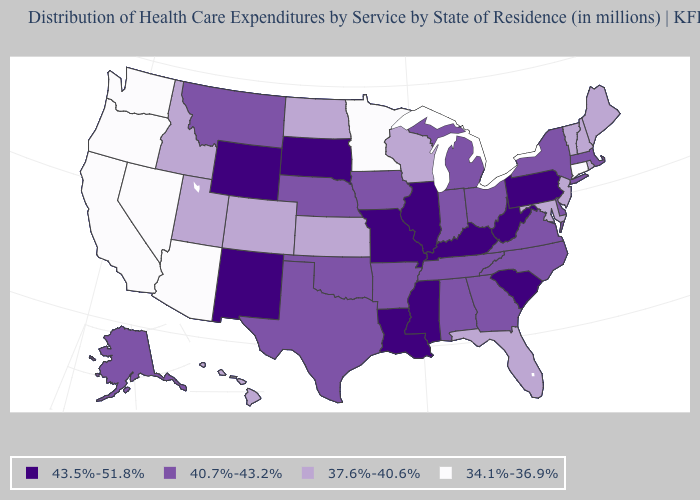What is the value of Connecticut?
Short answer required. 34.1%-36.9%. Among the states that border New Jersey , does Pennsylvania have the highest value?
Short answer required. Yes. What is the value of Maryland?
Keep it brief. 37.6%-40.6%. Which states hav the highest value in the South?
Concise answer only. Kentucky, Louisiana, Mississippi, South Carolina, West Virginia. What is the lowest value in states that border Georgia?
Short answer required. 37.6%-40.6%. What is the value of Massachusetts?
Concise answer only. 40.7%-43.2%. Among the states that border Kentucky , does Illinois have the highest value?
Short answer required. Yes. Which states have the highest value in the USA?
Write a very short answer. Illinois, Kentucky, Louisiana, Mississippi, Missouri, New Mexico, Pennsylvania, South Carolina, South Dakota, West Virginia, Wyoming. Does South Dakota have the same value as Pennsylvania?
Write a very short answer. Yes. Name the states that have a value in the range 34.1%-36.9%?
Concise answer only. Arizona, California, Connecticut, Minnesota, Nevada, Oregon, Washington. What is the lowest value in the MidWest?
Concise answer only. 34.1%-36.9%. Name the states that have a value in the range 37.6%-40.6%?
Short answer required. Colorado, Florida, Hawaii, Idaho, Kansas, Maine, Maryland, New Hampshire, New Jersey, North Dakota, Rhode Island, Utah, Vermont, Wisconsin. Among the states that border Rhode Island , does Massachusetts have the highest value?
Answer briefly. Yes. What is the highest value in states that border Florida?
Write a very short answer. 40.7%-43.2%. Does Nebraska have the highest value in the USA?
Quick response, please. No. 